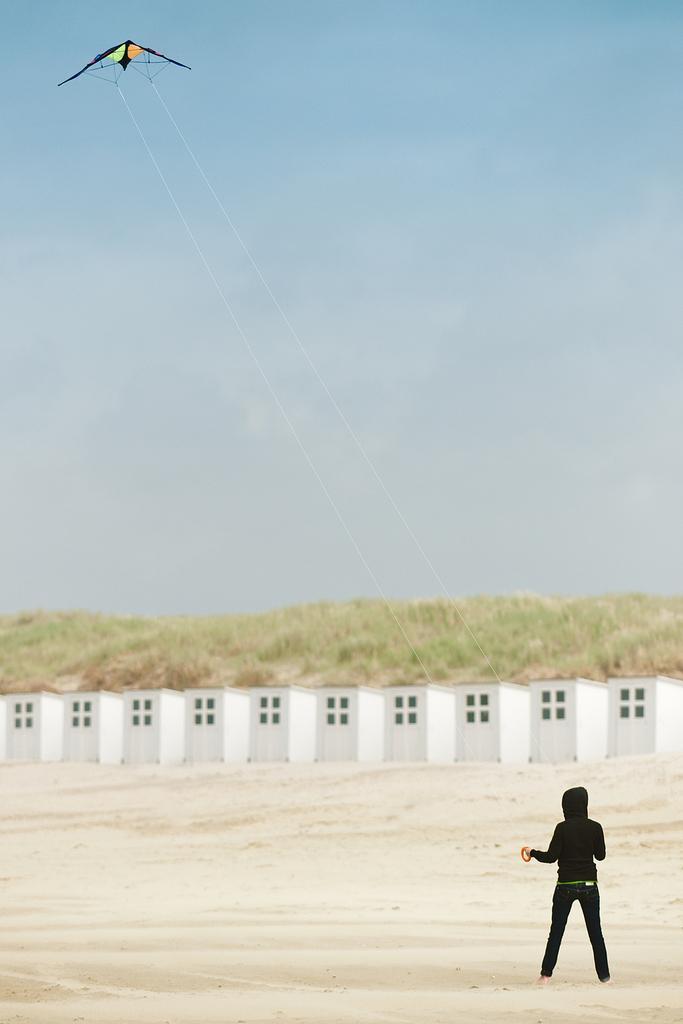How would you summarize this image in a sentence or two? In this image we can see a person standing on the sand and flying the kite. In the background we can see the constructed fence. We can also see the grass. Sky is also visible. 